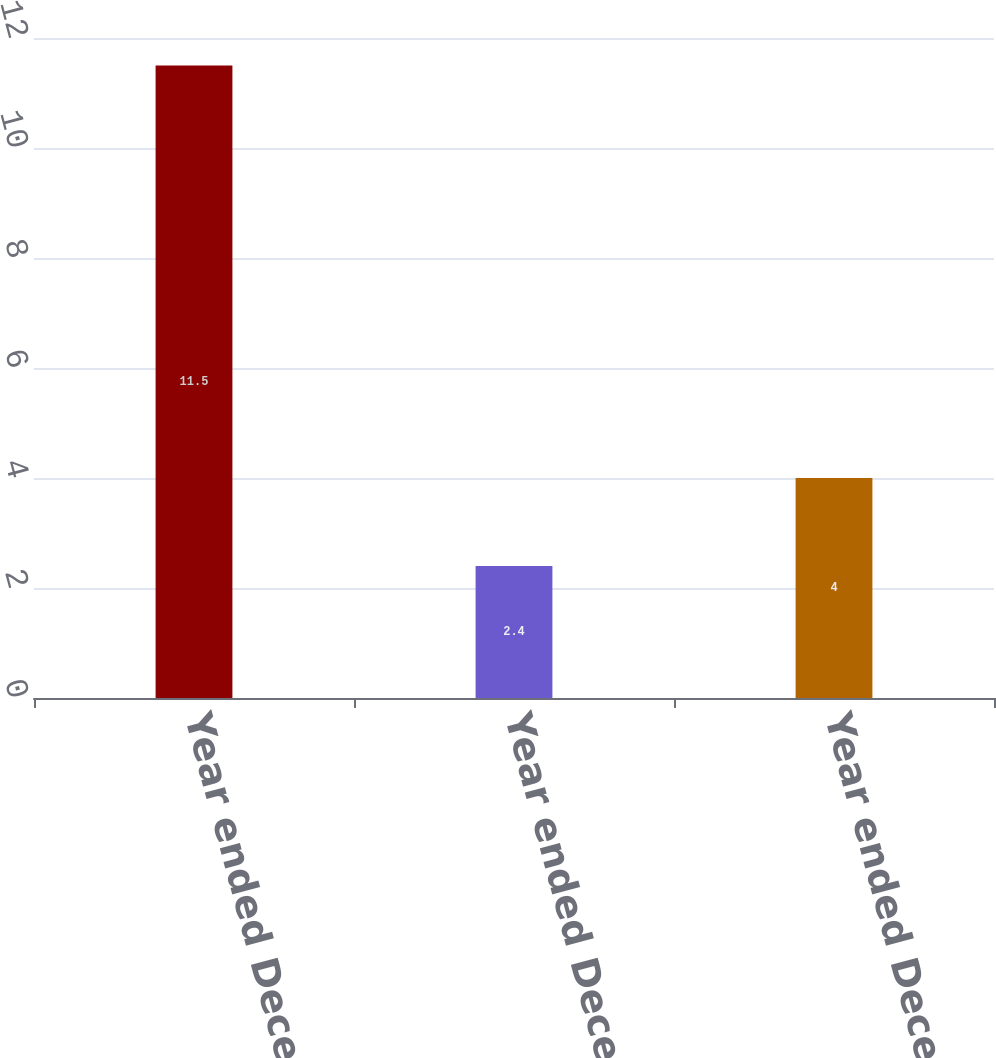<chart> <loc_0><loc_0><loc_500><loc_500><bar_chart><fcel>Year ended December 31 2014<fcel>Year ended December 31 2013<fcel>Year ended December 31 2012<nl><fcel>11.5<fcel>2.4<fcel>4<nl></chart> 